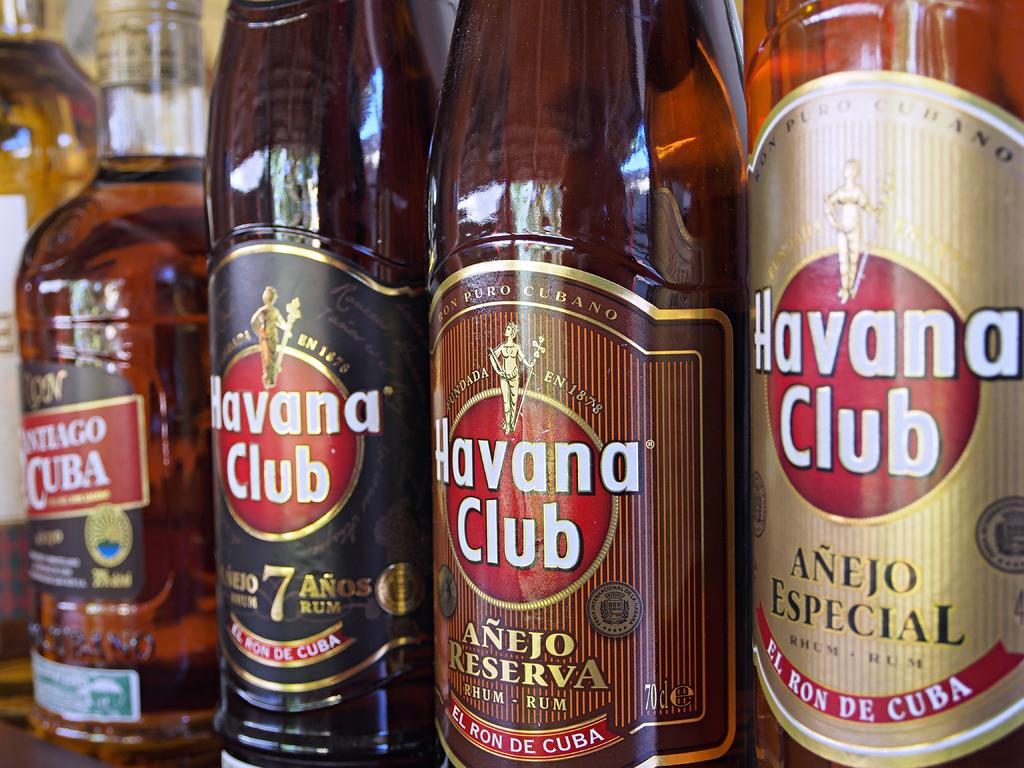<image>
Summarize the visual content of the image. Several bottles of Havana Club sit in a row on a shelf 